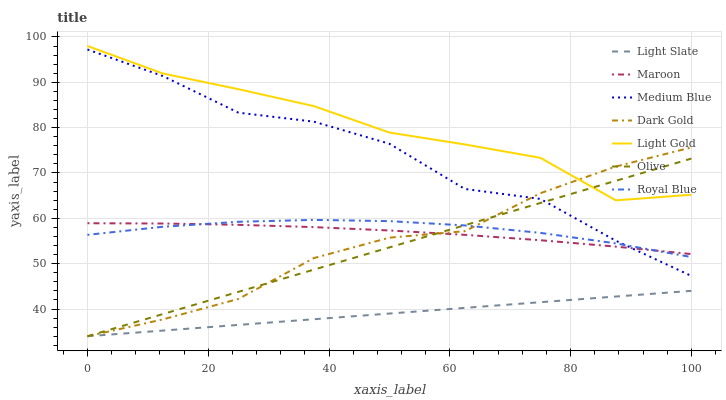Does Light Slate have the minimum area under the curve?
Answer yes or no. Yes. Does Light Gold have the maximum area under the curve?
Answer yes or no. Yes. Does Medium Blue have the minimum area under the curve?
Answer yes or no. No. Does Medium Blue have the maximum area under the curve?
Answer yes or no. No. Is Light Slate the smoothest?
Answer yes or no. Yes. Is Medium Blue the roughest?
Answer yes or no. Yes. Is Medium Blue the smoothest?
Answer yes or no. No. Is Light Slate the roughest?
Answer yes or no. No. Does Dark Gold have the lowest value?
Answer yes or no. Yes. Does Medium Blue have the lowest value?
Answer yes or no. No. Does Light Gold have the highest value?
Answer yes or no. Yes. Does Medium Blue have the highest value?
Answer yes or no. No. Is Light Slate less than Maroon?
Answer yes or no. Yes. Is Light Gold greater than Light Slate?
Answer yes or no. Yes. Does Dark Gold intersect Light Gold?
Answer yes or no. Yes. Is Dark Gold less than Light Gold?
Answer yes or no. No. Is Dark Gold greater than Light Gold?
Answer yes or no. No. Does Light Slate intersect Maroon?
Answer yes or no. No. 